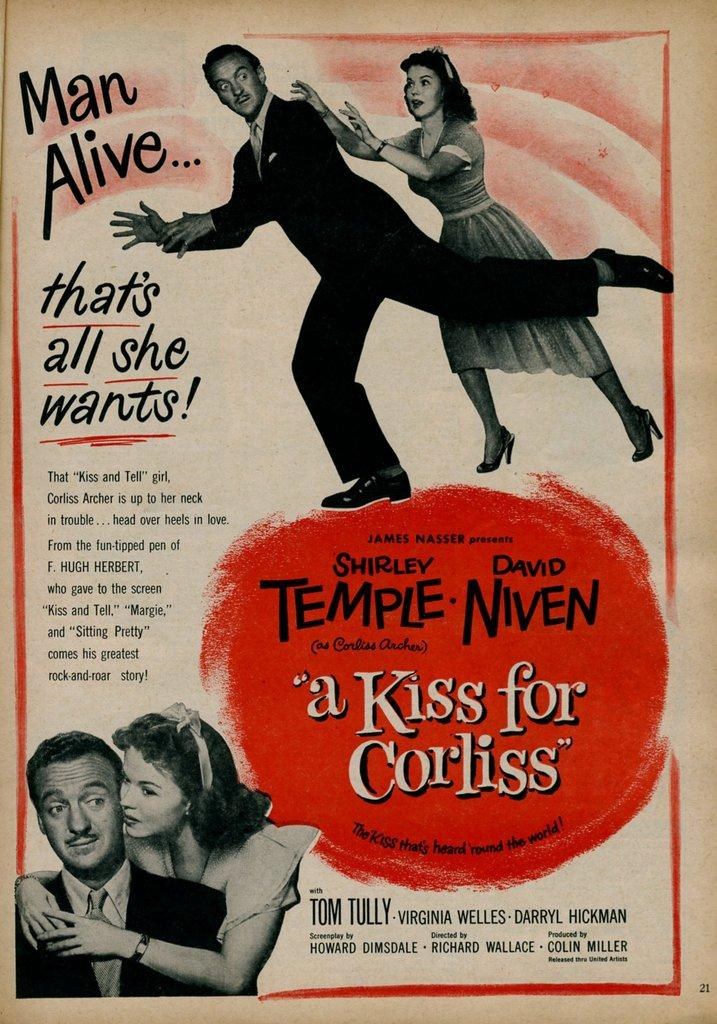<image>
Give a short and clear explanation of the subsequent image. Howard Dimsdale wrote the screenplay for a Kiss for Corliss. 